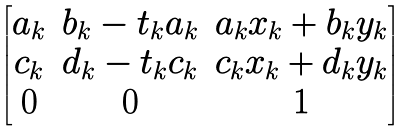Convert formula to latex. <formula><loc_0><loc_0><loc_500><loc_500>\begin{bmatrix} a _ { k } & b _ { k } - t _ { k } a _ { k } & a _ { k } x _ { k } + b _ { k } y _ { k } \\ c _ { k } & d _ { k } - t _ { k } c _ { k } & c _ { k } x _ { k } + d _ { k } y _ { k } \\ 0 & 0 & 1 \end{bmatrix}</formula> 